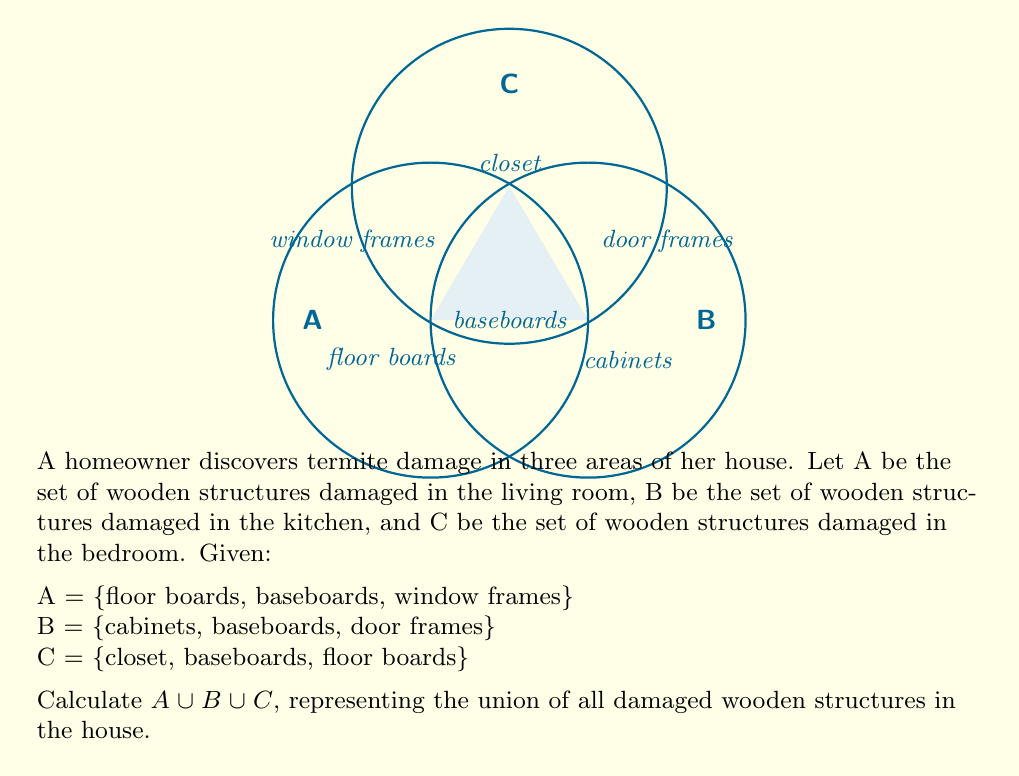Provide a solution to this math problem. To find the union of sets A, B, and C, we need to list all unique elements that appear in at least one of the sets. Let's approach this step-by-step:

1) First, let's list all elements from set A:
   $A = \{$floor boards, baseboards, window frames$\}$

2) Now, let's add any new elements from set B that are not already in our list:
   $A \cup B = \{$floor boards, baseboards, window frames, cabinets, door frames$\}$

3) Finally, let's add any new elements from set C that are not already in our list:
   $A \cup B \cup C = \{$floor boards, baseboards, window frames, cabinets, door frames, closet$\}$

4) We can verify that this set contains all unique elements from A, B, and C.

5) The resulting set has 6 elements, representing all the unique wooden structures damaged by termites in the house.

The union operation $\cup$ combines all elements from the given sets, eliminating any duplicates. In this case, "baseboards" and "floor boards" appeared in multiple sets but are only listed once in the final union.
Answer: $A \cup B \cup C = \{$floor boards, baseboards, window frames, cabinets, door frames, closet$\}$ 